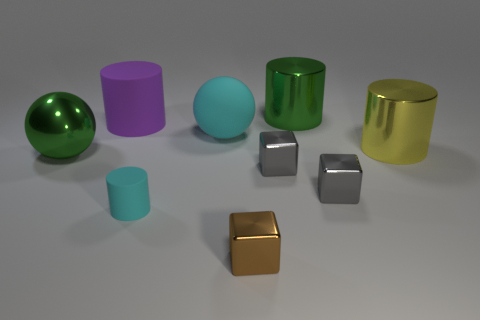How many tiny objects are red metallic balls or yellow metallic objects?
Ensure brevity in your answer.  0. Are there more large rubber objects on the left side of the small rubber thing than large cyan spheres that are on the left side of the purple rubber thing?
Your answer should be very brief. Yes. Is the material of the tiny cyan object the same as the large ball that is on the left side of the small matte cylinder?
Your answer should be compact. No. What is the color of the big rubber cylinder?
Your response must be concise. Purple. There is a green metallic object that is left of the large green cylinder; what is its shape?
Make the answer very short. Sphere. How many brown objects are either big metal balls or metal cylinders?
Your answer should be compact. 0. What is the color of the other big cylinder that is made of the same material as the cyan cylinder?
Your answer should be very brief. Purple. There is a small matte cylinder; does it have the same color as the metal cylinder that is in front of the cyan rubber sphere?
Your answer should be very brief. No. What color is the cylinder that is both behind the big yellow metal cylinder and to the right of the small cyan cylinder?
Provide a short and direct response. Green. What number of big cylinders are to the right of the small cyan thing?
Offer a very short reply. 2. 